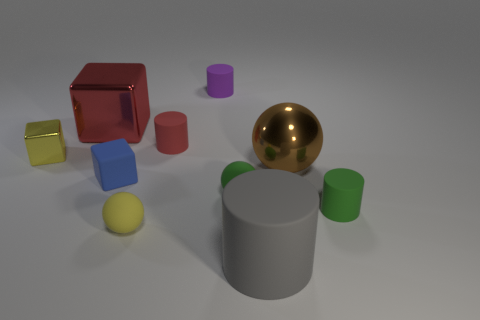Subtract all green cylinders. How many cylinders are left? 3 Subtract all yellow balls. How many balls are left? 2 Subtract all cubes. How many objects are left? 7 Subtract all blue cubes. How many purple cylinders are left? 1 Add 7 tiny green matte objects. How many tiny green matte objects are left? 9 Add 9 tiny green balls. How many tiny green balls exist? 10 Subtract 0 gray blocks. How many objects are left? 10 Subtract 3 cubes. How many cubes are left? 0 Subtract all blue blocks. Subtract all cyan cylinders. How many blocks are left? 2 Subtract all tiny green balls. Subtract all large things. How many objects are left? 6 